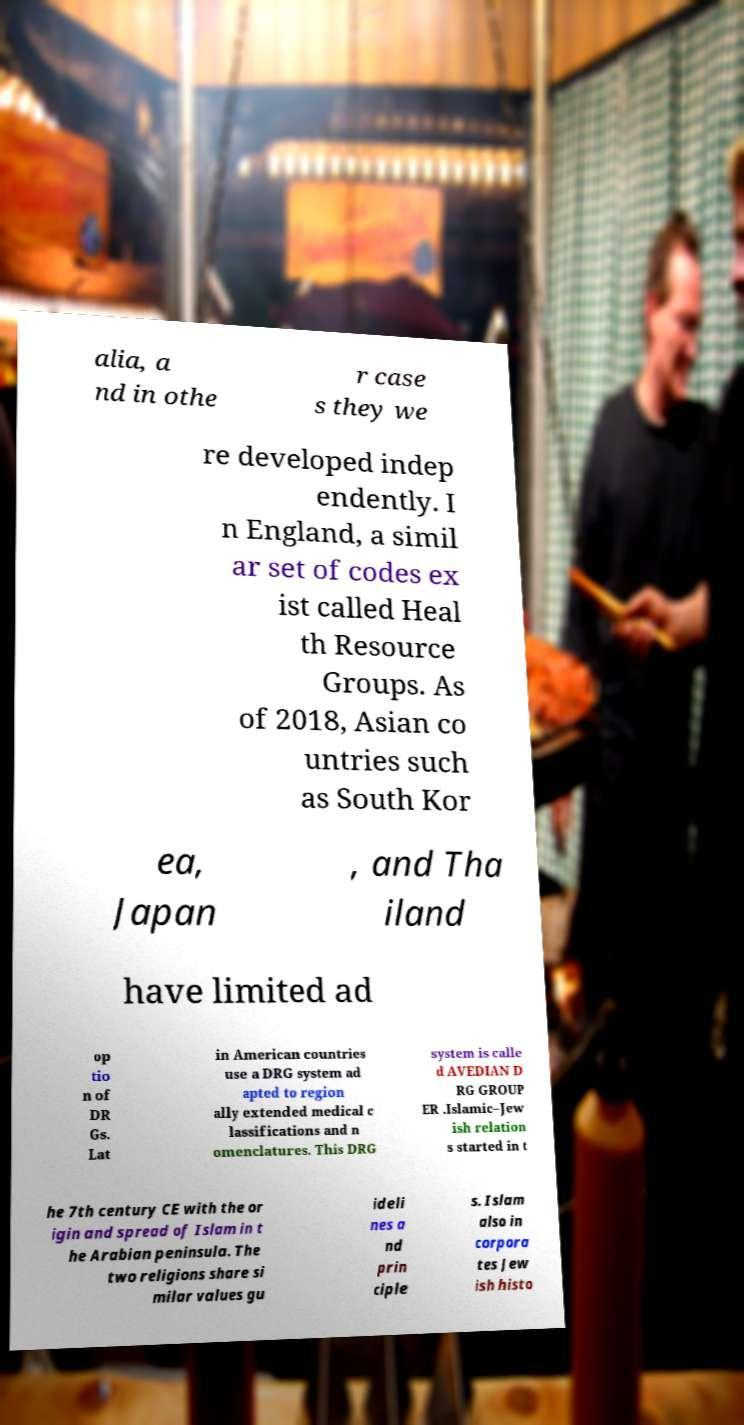I need the written content from this picture converted into text. Can you do that? alia, a nd in othe r case s they we re developed indep endently. I n England, a simil ar set of codes ex ist called Heal th Resource Groups. As of 2018, Asian co untries such as South Kor ea, Japan , and Tha iland have limited ad op tio n of DR Gs. Lat in American countries use a DRG system ad apted to region ally extended medical c lassifications and n omenclatures. This DRG system is calle d AVEDIAN D RG GROUP ER .Islamic–Jew ish relation s started in t he 7th century CE with the or igin and spread of Islam in t he Arabian peninsula. The two religions share si milar values gu ideli nes a nd prin ciple s. Islam also in corpora tes Jew ish histo 